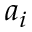<formula> <loc_0><loc_0><loc_500><loc_500>a _ { i }</formula> 